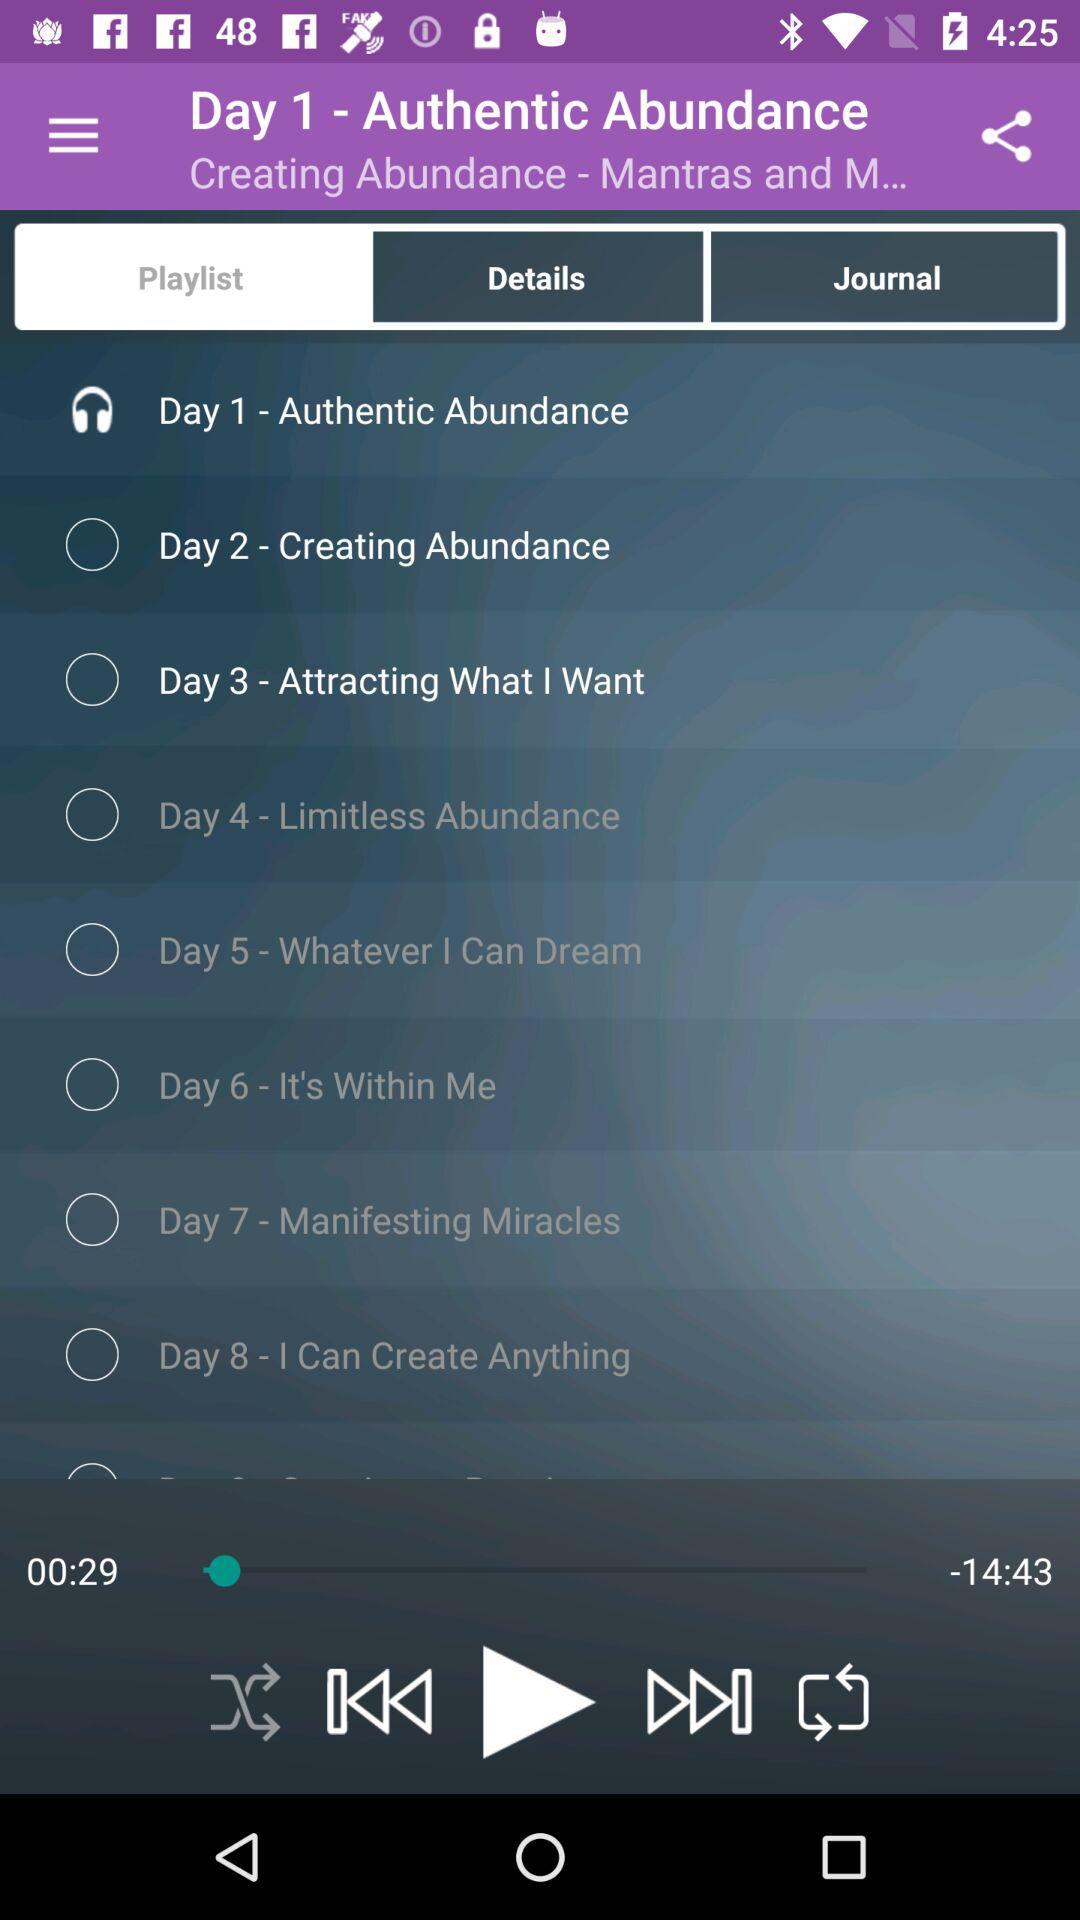Which tab is selected? The selected tab is "Playlist". 